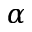Convert formula to latex. <formula><loc_0><loc_0><loc_500><loc_500>\alpha</formula> 